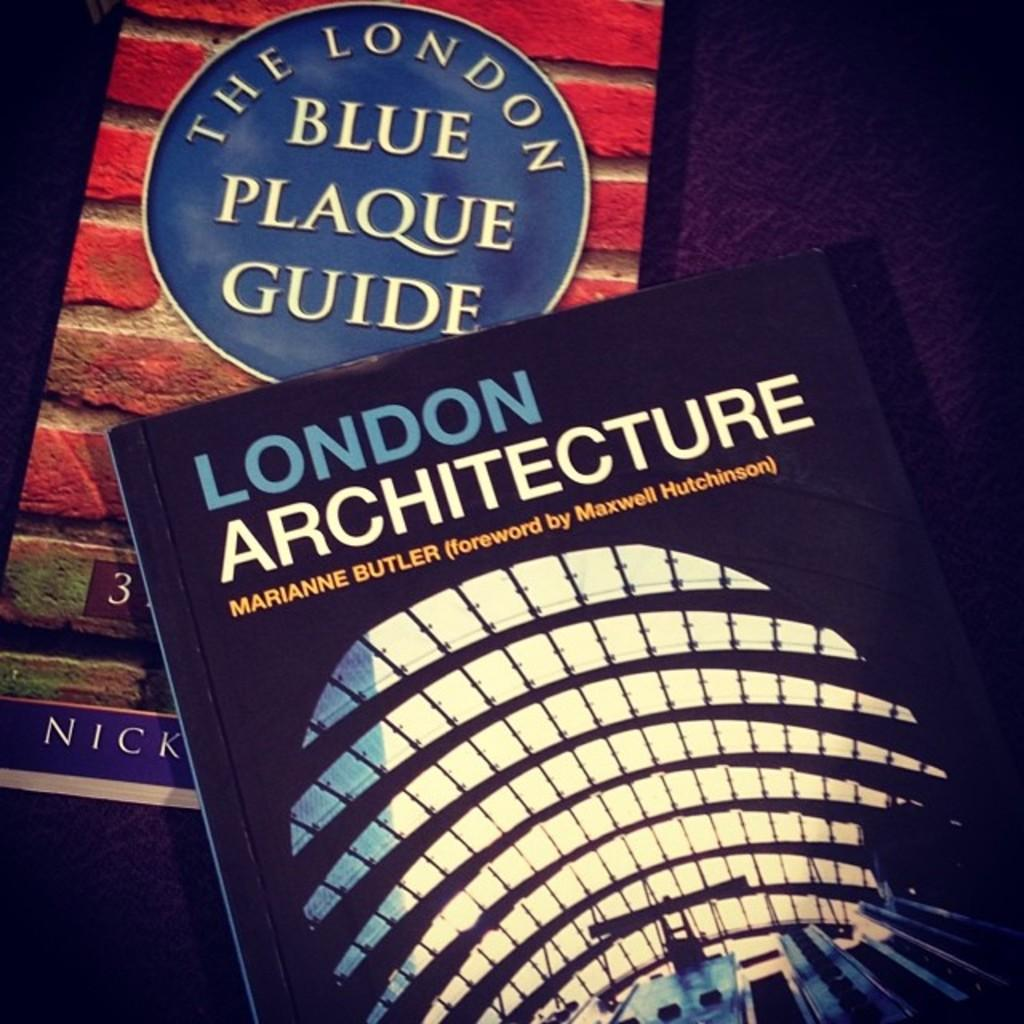<image>
Create a compact narrative representing the image presented. A book titled " London Architecture" by Marianne Butler. 